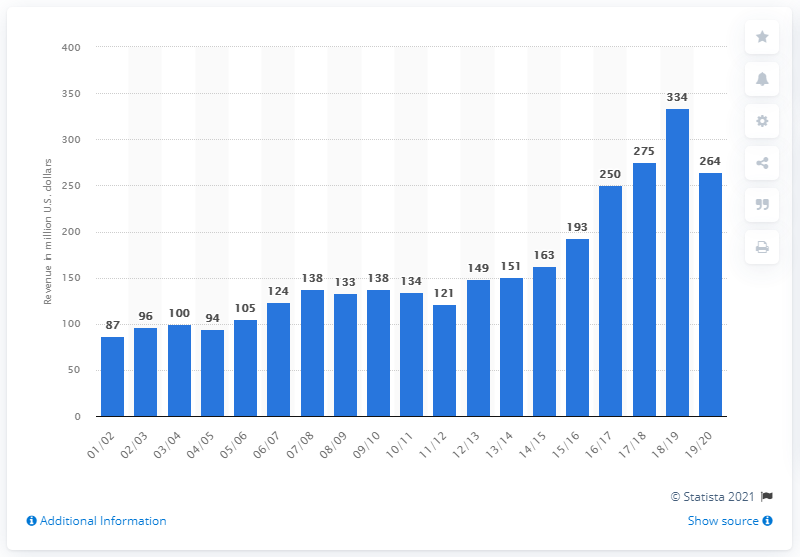Identify some key points in this picture. The estimated revenue of the National Basketball Association franchise in the 2019/2020 season was approximately $264 million. 